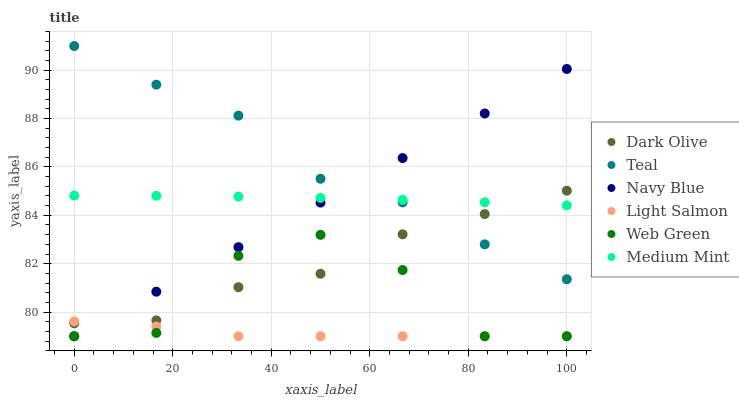Does Light Salmon have the minimum area under the curve?
Answer yes or no. Yes. Does Teal have the maximum area under the curve?
Answer yes or no. Yes. Does Navy Blue have the minimum area under the curve?
Answer yes or no. No. Does Navy Blue have the maximum area under the curve?
Answer yes or no. No. Is Navy Blue the smoothest?
Answer yes or no. Yes. Is Web Green the roughest?
Answer yes or no. Yes. Is Light Salmon the smoothest?
Answer yes or no. No. Is Light Salmon the roughest?
Answer yes or no. No. Does Light Salmon have the lowest value?
Answer yes or no. Yes. Does Dark Olive have the lowest value?
Answer yes or no. No. Does Teal have the highest value?
Answer yes or no. Yes. Does Navy Blue have the highest value?
Answer yes or no. No. Is Web Green less than Teal?
Answer yes or no. Yes. Is Medium Mint greater than Light Salmon?
Answer yes or no. Yes. Does Light Salmon intersect Web Green?
Answer yes or no. Yes. Is Light Salmon less than Web Green?
Answer yes or no. No. Is Light Salmon greater than Web Green?
Answer yes or no. No. Does Web Green intersect Teal?
Answer yes or no. No. 